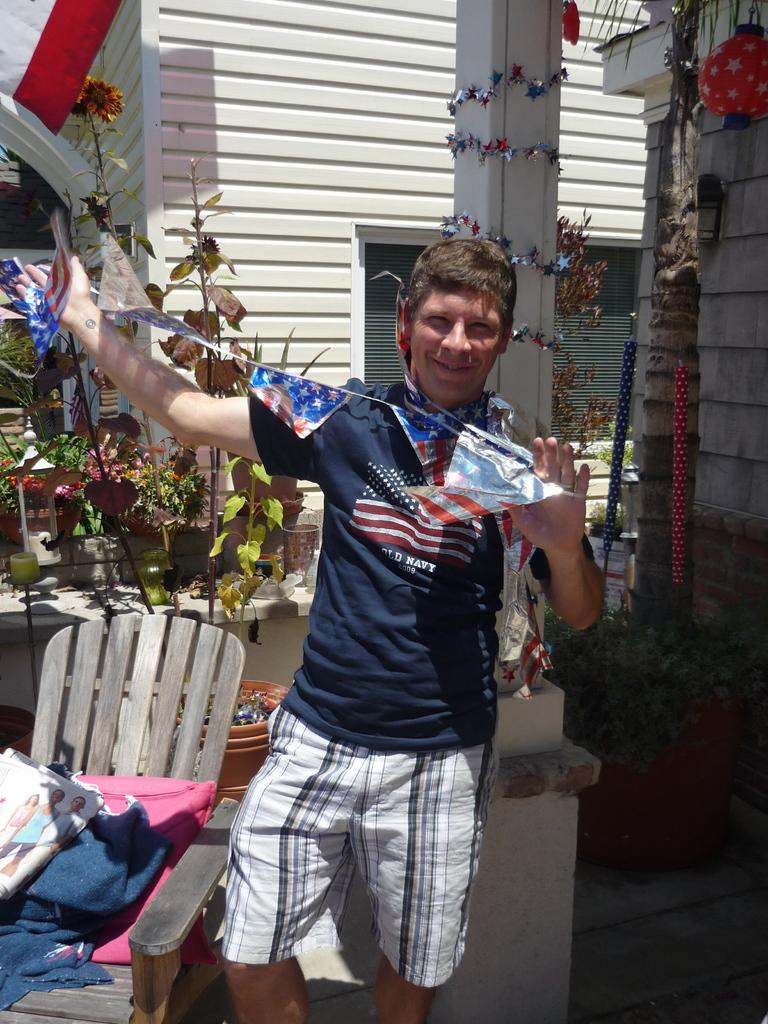What is the man in the image holding? The man is holding flags in his hands. What can be seen in the background of the image? There is a building, plants, chairs, and a pillow in the background of the image. Can you describe the building in the background? The building in the background is not described in the provided facts, so it cannot be described. What type of stove can be seen in the image? There is no stove present in the image. What range of emotions does the man display while holding the flags? The provided facts do not mention the man's emotions, so it cannot be determined from the image. 